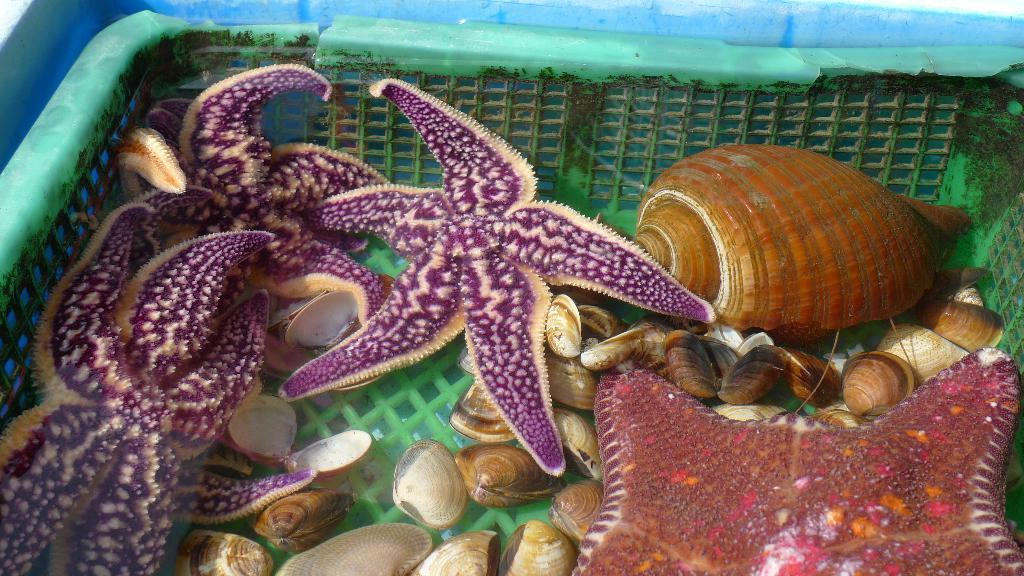What type of objects can be seen in the image? There are shells and starfish in the image. Where are the shells and starfish located? The shells and starfish are in a tub. What type of glass can be seen in the image? There is no glass present in the image; it features shells and starfish in a tub. 